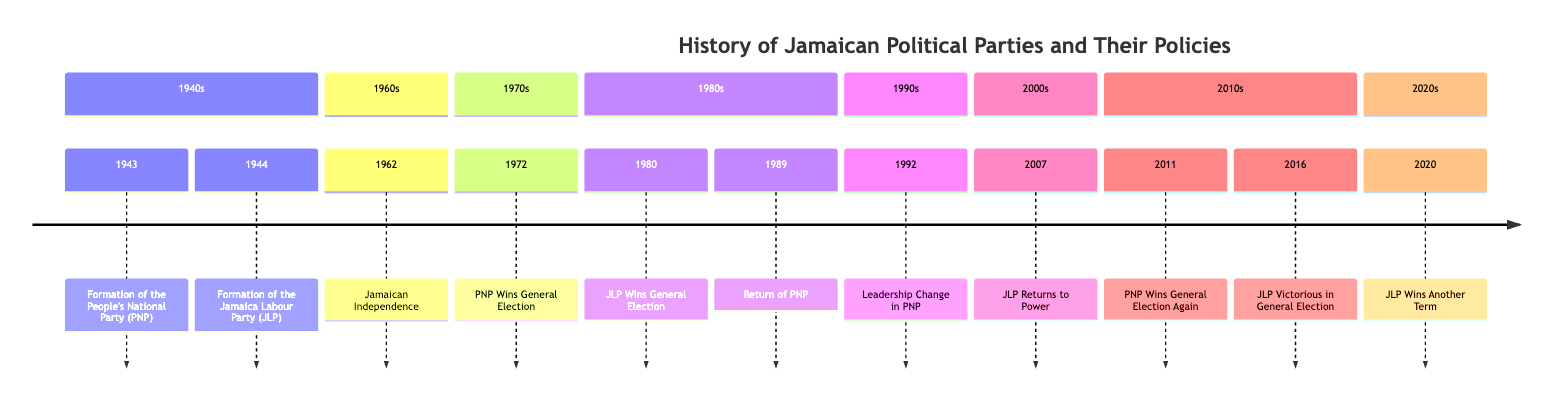What year was the People's National Party (PNP) formed? The timeline indicates that the People's National Party (PNP) was formed in 1943.
Answer: 1943 Who led the JLP when it won the general election in 1980? According to the timeline, Edward Seaga was the leader of the JLP when it won the general election in 1980.
Answer: Edward Seaga How many times did the PNP win general elections in the 2010s? The timeline shows that the PNP won the general election in 2011, which totals one win in the 2010s.
Answer: 1 Which party was in power during Jamaican independence in 1962? The timeline states that both the PNP and JLP played pivotal roles in the independence process in 1962, indicating a collaborative effort between the two parties.
Answer: PNP and JLP What major economic policy focus did the JLP have when it returned to power in 2007? The JLP's policies when led by Bruce Golding in 2007 focused on crime reduction and economic stability, which are key aspects of their governance.
Answer: Crime reduction and economic stability What was the outcome of the 1972 general election? The timeline explicitly states that the PNP, under Michael Manley's leadership, won the general election in 1972, emphasizing a successful campaign.
Answer: PNP Wins General Election Who succeeded Michael Manley as Prime Minister of the PNP? The timeline indicates that P.J. Patterson became the Prime Minister after Michael Manley stepped down in 1992, signifying a leadership change within the party.
Answer: P.J. Patterson What did Andrew Holness focus on during his terms starting in 2016? From the timeline, it’s clear that Andrew Holness focused on economic growth, education, and healthcare improvements during his terms beginning in 2016.
Answer: Economic growth, education, and healthcare improvements 